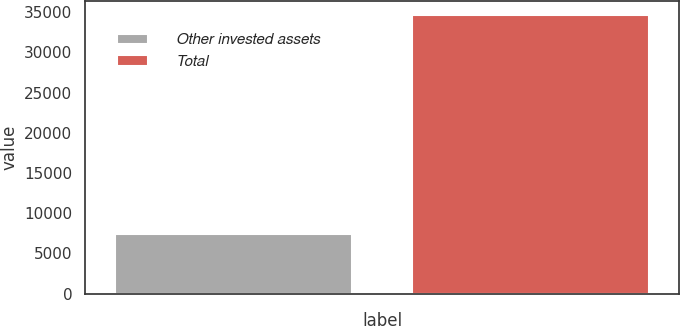<chart> <loc_0><loc_0><loc_500><loc_500><bar_chart><fcel>Other invested assets<fcel>Total<nl><fcel>7414<fcel>34656<nl></chart> 